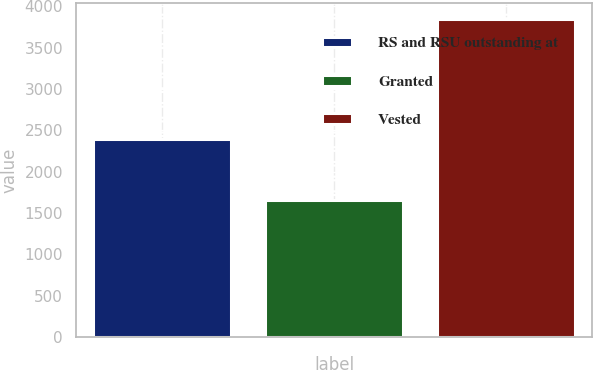Convert chart to OTSL. <chart><loc_0><loc_0><loc_500><loc_500><bar_chart><fcel>RS and RSU outstanding at<fcel>Granted<fcel>Vested<nl><fcel>2390.3<fcel>1657<fcel>3845<nl></chart> 